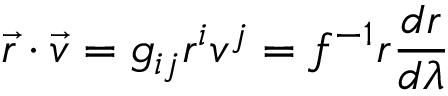Convert formula to latex. <formula><loc_0><loc_0><loc_500><loc_500>\vec { r } \cdot \vec { v } = g _ { i j } r ^ { i } v ^ { j } = f ^ { - 1 } r \frac { d r } { d \lambda }</formula> 